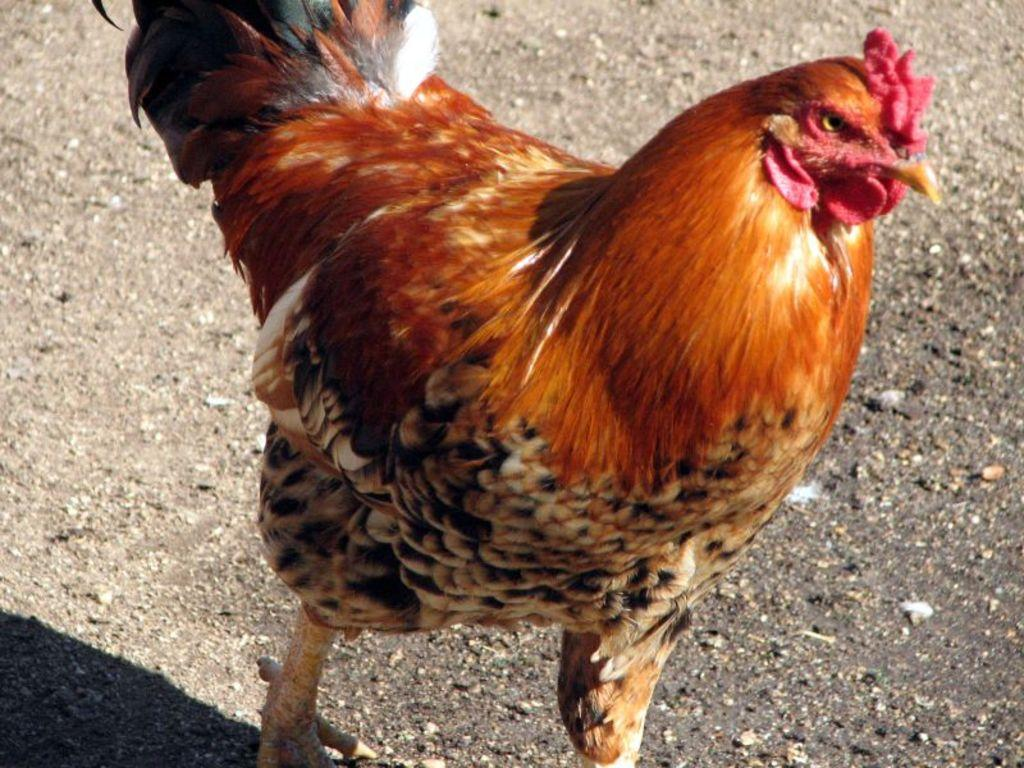What animal is in the picture? There is a rooster in the picture. What colors can be seen on the rooster? The rooster has brown, black, and cream colors. What type of environment is visible in the background of the picture? There is land visible in the background of the picture. What type of balloon can be seen floating in the background of the picture? There is no balloon present in the image; it only features a rooster and land in the background. 